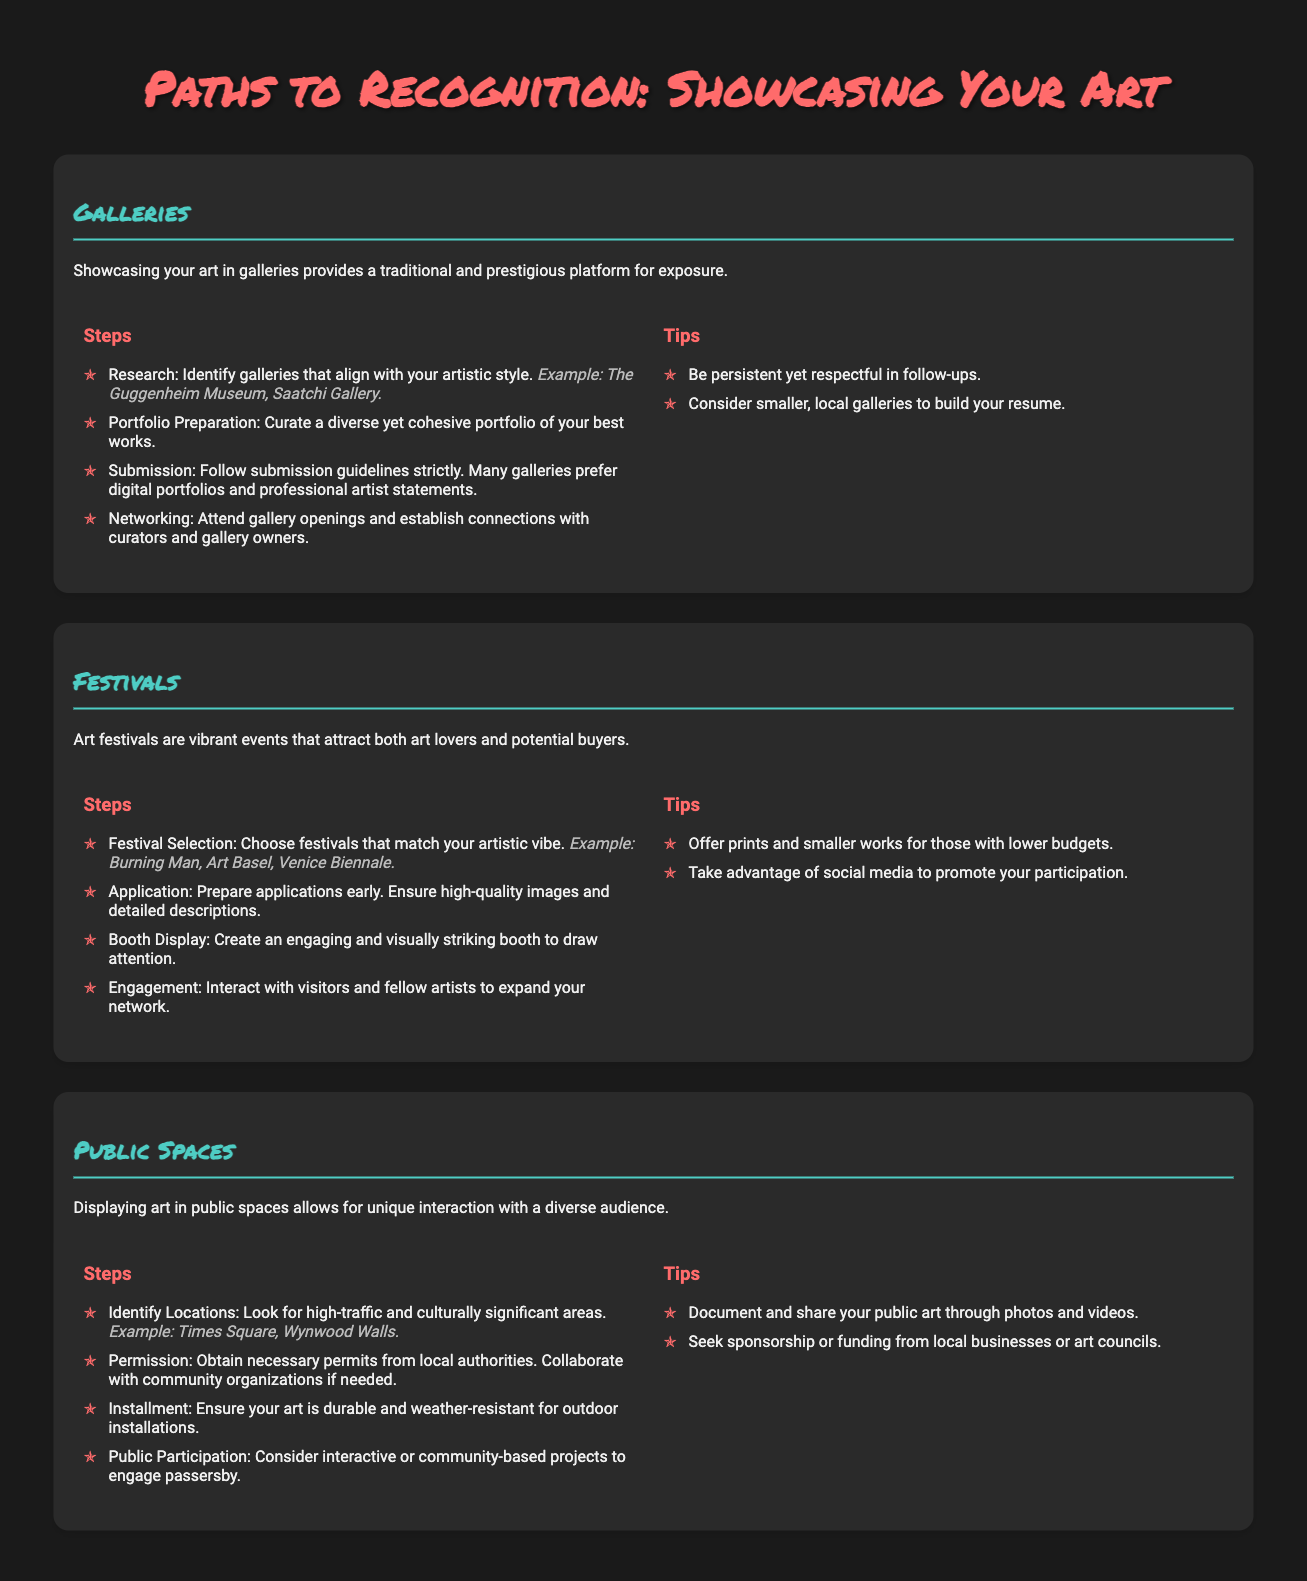What are three examples of galleries? The document lists examples such as The Guggenheim Museum and Saatchi Gallery.
Answer: The Guggenheim Museum, Saatchi Gallery Name one art festival mentioned. The document names several festivals including Burning Man and Art Basel.
Answer: Burning Man What should your art installation be for outdoor public spaces? The document specifies that art must be durable and weather-resistant for outdoor installations.
Answer: Durable and weather-resistant How many steps are there for showcasing art in galleries? The document outlines four steps for showcasing art in galleries.
Answer: Four What type of art is suggested to offer at festivals for lower budgets? The document suggests offering prints and smaller works for those with lower budgets.
Answer: Prints and smaller works What is a crucial aspect of public space art related to community engagement? The document emphasizes considering interactive or community-based projects to engage passersby.
Answer: Interactive or community-based projects Which color is used for the subheadings in the paths? The document indicates that subheadings in the paths use the color #4ecdc4.
Answer: #4ecdc4 What is a benefit of attending festival openings? The document states that interacting with visitors and fellow artists expands your network.
Answer: Expand your network How should portfolios be prepared for gallery submissions? The document advises curating a diverse yet cohesive portfolio of your best works.
Answer: Diverse yet cohesive portfolio 